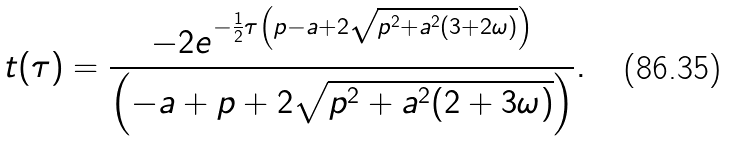Convert formula to latex. <formula><loc_0><loc_0><loc_500><loc_500>t ( \tau ) = \frac { - 2 e ^ { - \frac { 1 } { 2 } \tau \left ( p - a + 2 \sqrt { p ^ { 2 } + a ^ { 2 } ( 3 + 2 \omega ) } \right ) } } { \left ( - a + p + 2 \sqrt { p ^ { 2 } + a ^ { 2 } ( 2 + 3 \omega ) } \right ) } .</formula> 